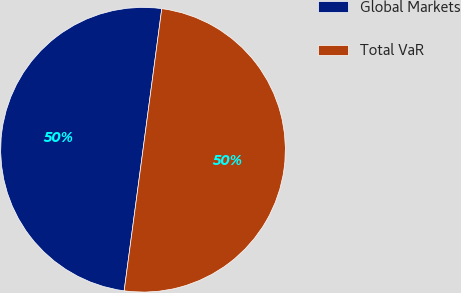Convert chart to OTSL. <chart><loc_0><loc_0><loc_500><loc_500><pie_chart><fcel>Global Markets<fcel>Total VaR<nl><fcel>49.99%<fcel>50.01%<nl></chart> 